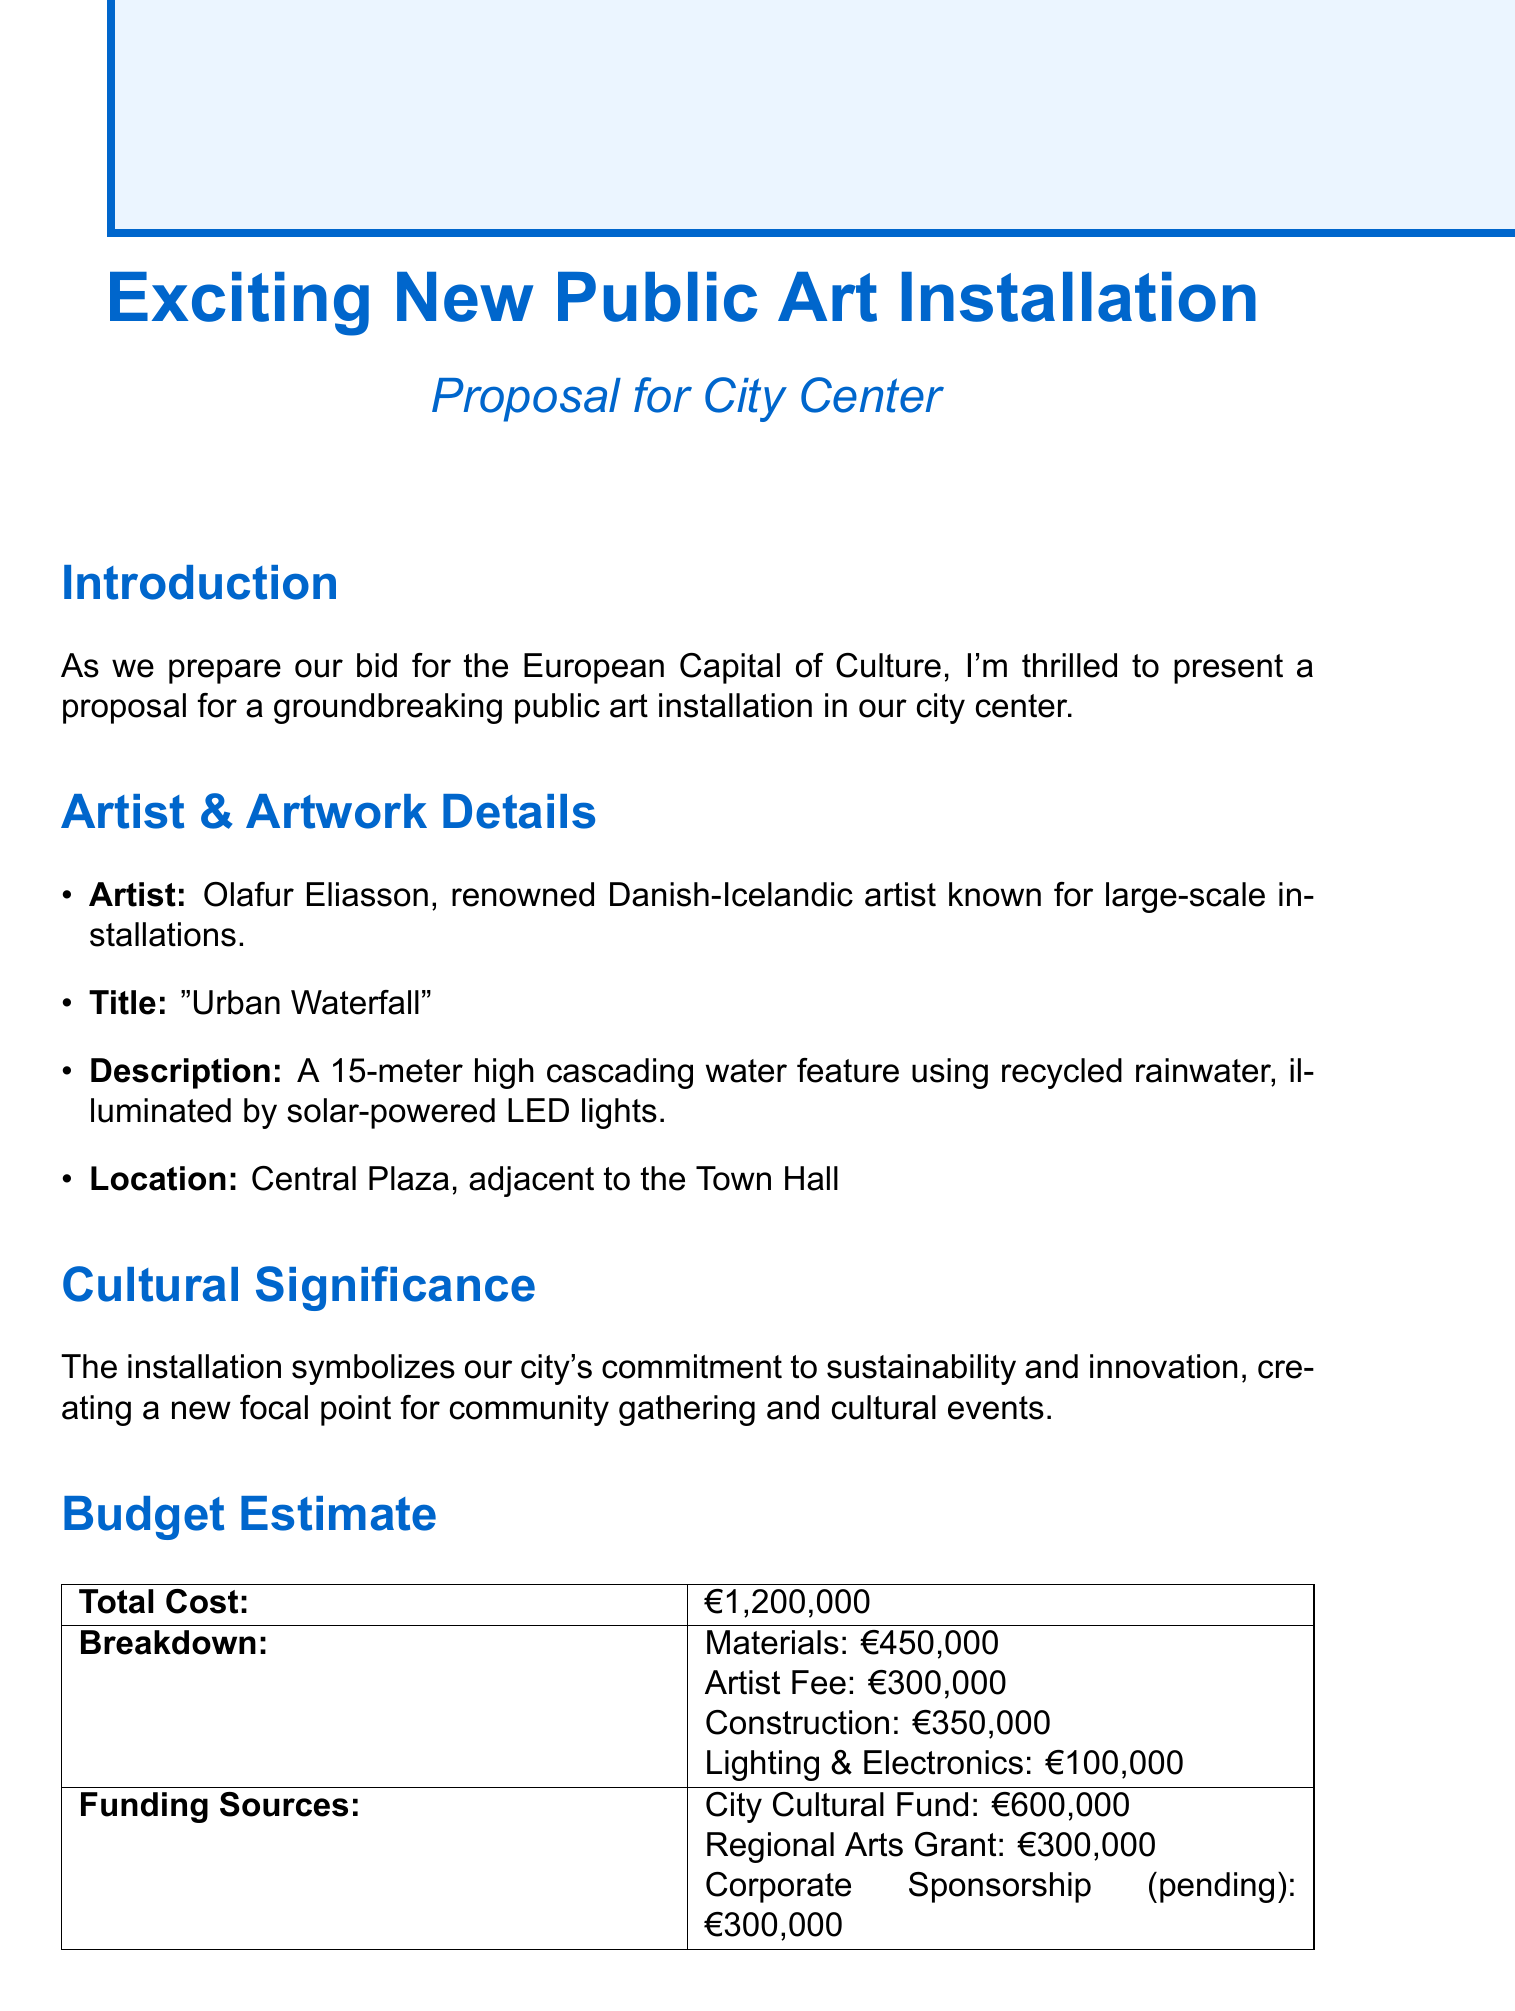What is the title of the artwork? The title of the artwork is mentioned in the artwork details section of the document as "Urban Waterfall."
Answer: Urban Waterfall Who is the artist of the installation? The artist is identified in the artist information section of the document as Olafur Eliasson.
Answer: Olafur Eliasson What is the total cost of the installation? The total cost is found in the budget estimate section and is specified as €1,200,000.
Answer: €1,200,000 Where is the installation located? The location is mentioned in the artwork details, indicating it is in the Central Plaza, adjacent to the Town Hall.
Answer: Central Plaza, adjacent to the Town Hall What month is the construction scheduled to start? The document specifies that construction is set to start in March 2024, according to the timeline section.
Answer: March 2024 What is the funding source from the City Cultural Fund? The funding source amounts are detailed in the budget estimate, indicating that the City Cultural Fund provides €600,000.
Answer: €600,000 What is the estimated completion date for the project? The estimated completion date is provided in the timeline section as November 2024.
Answer: November 2024 What is the cultural significance of the installation? The cultural significance is described in the document as symbolizing the city's commitment to sustainability and innovation.
Answer: Commitment to sustainability and innovation How will community engagement be conducted? Community engagement plans are outlined in the document, which involves local schools and community groups in workshops with the artist.
Answer: Workshops with the artist 